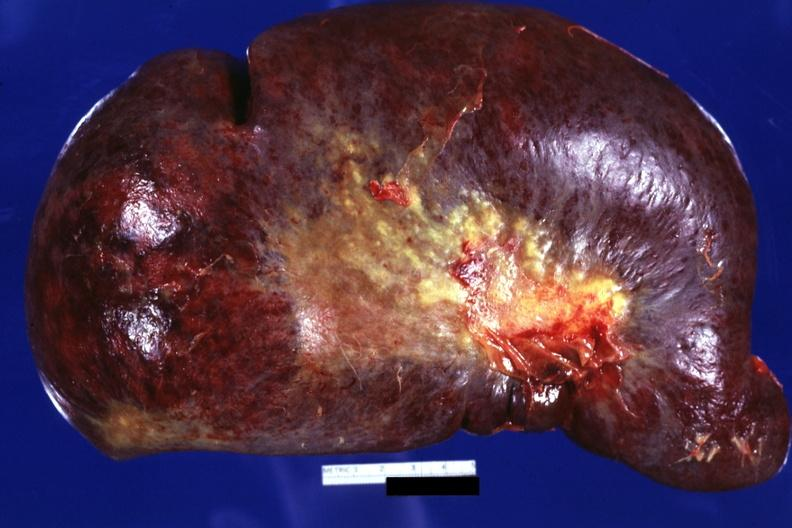where is this part in?
Answer the question using a single word or phrase. Spleen 